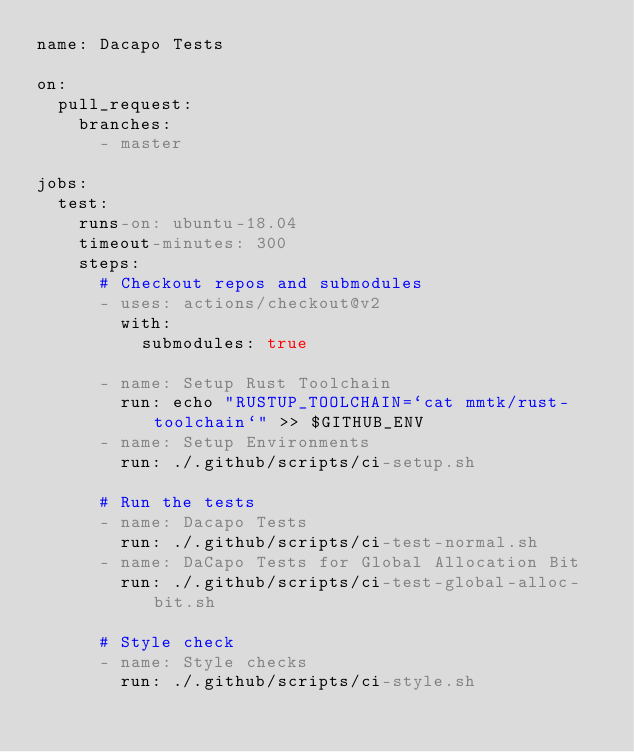Convert code to text. <code><loc_0><loc_0><loc_500><loc_500><_YAML_>name: Dacapo Tests

on:
  pull_request:
    branches:
      - master

jobs:
  test:
    runs-on: ubuntu-18.04
    timeout-minutes: 300
    steps:
      # Checkout repos and submodules
      - uses: actions/checkout@v2
        with:
          submodules: true

      - name: Setup Rust Toolchain
        run: echo "RUSTUP_TOOLCHAIN=`cat mmtk/rust-toolchain`" >> $GITHUB_ENV
      - name: Setup Environments
        run: ./.github/scripts/ci-setup.sh

      # Run the tests
      - name: Dacapo Tests
        run: ./.github/scripts/ci-test-normal.sh
      - name: DaCapo Tests for Global Allocation Bit
        run: ./.github/scripts/ci-test-global-alloc-bit.sh

      # Style check
      - name: Style checks
        run: ./.github/scripts/ci-style.sh
</code> 